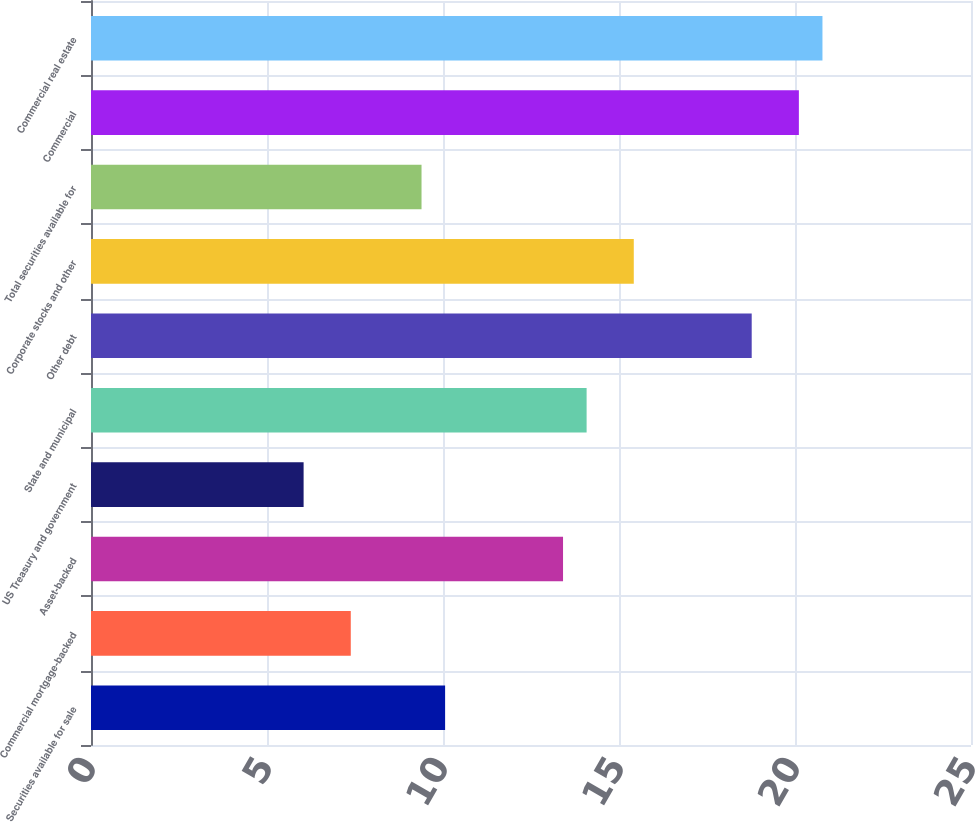Convert chart to OTSL. <chart><loc_0><loc_0><loc_500><loc_500><bar_chart><fcel>Securities available for sale<fcel>Commercial mortgage-backed<fcel>Asset-backed<fcel>US Treasury and government<fcel>State and municipal<fcel>Other debt<fcel>Corporate stocks and other<fcel>Total securities available for<fcel>Commercial<fcel>Commercial real estate<nl><fcel>10.06<fcel>7.38<fcel>13.41<fcel>6.04<fcel>14.08<fcel>18.77<fcel>15.42<fcel>9.39<fcel>20.11<fcel>20.78<nl></chart> 